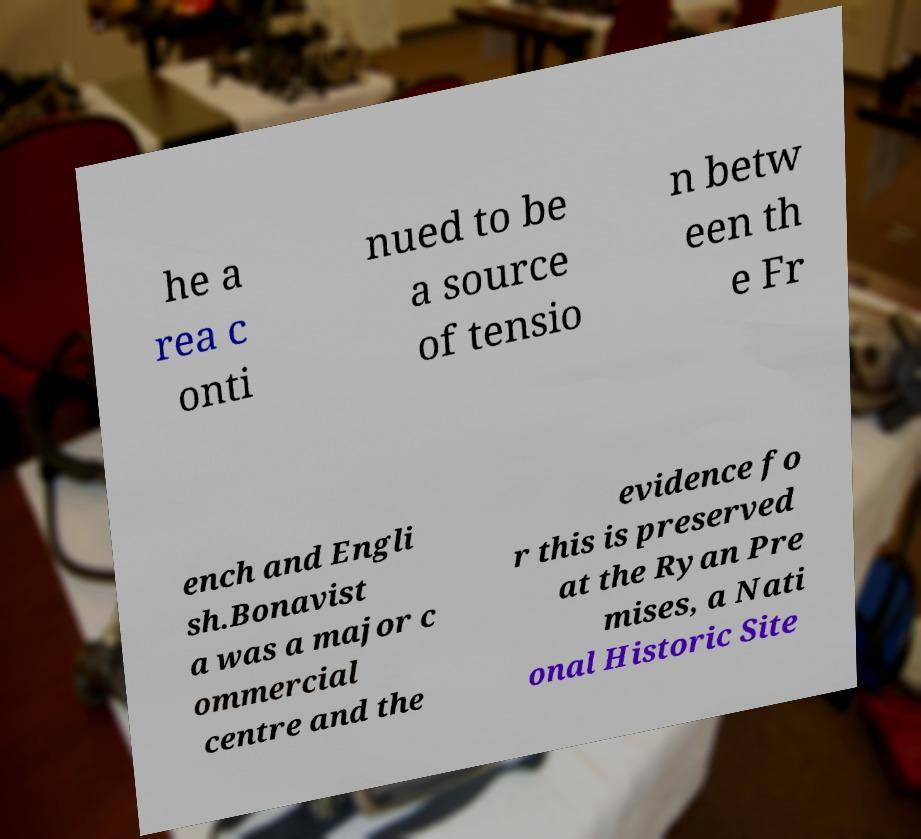Please read and relay the text visible in this image. What does it say? he a rea c onti nued to be a source of tensio n betw een th e Fr ench and Engli sh.Bonavist a was a major c ommercial centre and the evidence fo r this is preserved at the Ryan Pre mises, a Nati onal Historic Site 